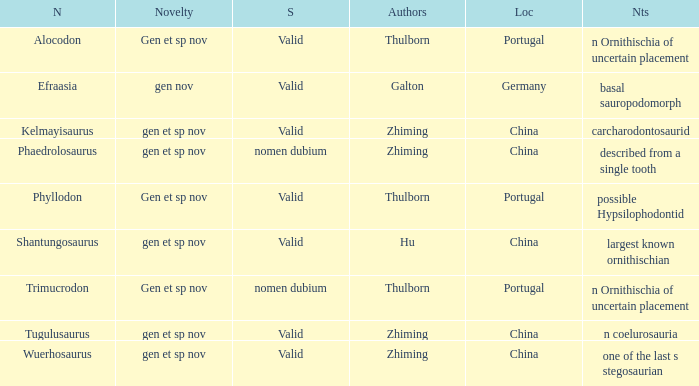What is the Status of the dinosaur, whose notes are, "n coelurosauria"? Valid. 